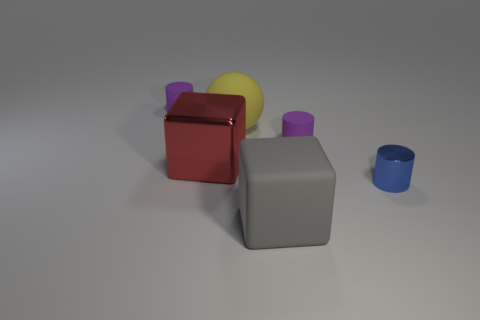Do the metal block and the yellow object have the same size?
Ensure brevity in your answer.  Yes. What material is the red object?
Ensure brevity in your answer.  Metal. There is a small purple rubber object that is left of the large rubber sphere; is its shape the same as the big gray rubber thing?
Your answer should be very brief. No. How many things are either large yellow rubber balls or small matte things?
Ensure brevity in your answer.  3. Is the cube in front of the red cube made of the same material as the yellow sphere?
Make the answer very short. Yes. What size is the yellow sphere?
Provide a short and direct response. Large. What number of balls are either rubber things or large red metal objects?
Make the answer very short. 1. Is the number of metallic cylinders to the left of the rubber cube the same as the number of big spheres that are behind the yellow object?
Offer a terse response. Yes. What is the size of the object that is in front of the big red thing and to the left of the small blue cylinder?
Offer a terse response. Large. There is a large gray object; are there any matte things behind it?
Make the answer very short. Yes. 